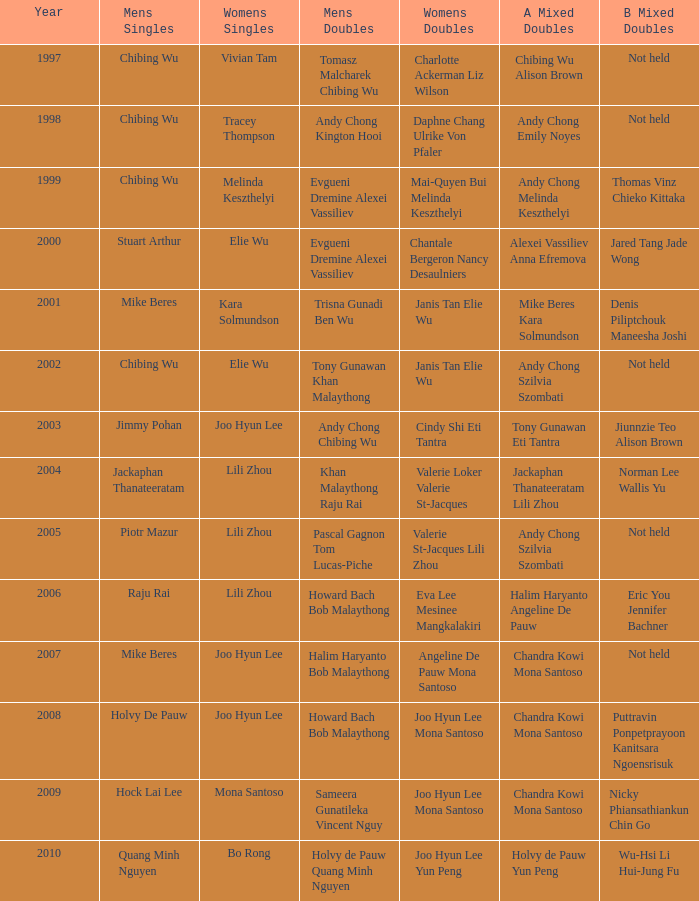What is the least year when men's singles is Raju Rai? 2006.0. Can you parse all the data within this table? {'header': ['Year', 'Mens Singles', 'Womens Singles', 'Mens Doubles', 'Womens Doubles', 'A Mixed Doubles', 'B Mixed Doubles'], 'rows': [['1997', 'Chibing Wu', 'Vivian Tam', 'Tomasz Malcharek Chibing Wu', 'Charlotte Ackerman Liz Wilson', 'Chibing Wu Alison Brown', 'Not held'], ['1998', 'Chibing Wu', 'Tracey Thompson', 'Andy Chong Kington Hooi', 'Daphne Chang Ulrike Von Pfaler', 'Andy Chong Emily Noyes', 'Not held'], ['1999', 'Chibing Wu', 'Melinda Keszthelyi', 'Evgueni Dremine Alexei Vassiliev', 'Mai-Quyen Bui Melinda Keszthelyi', 'Andy Chong Melinda Keszthelyi', 'Thomas Vinz Chieko Kittaka'], ['2000', 'Stuart Arthur', 'Elie Wu', 'Evgueni Dremine Alexei Vassiliev', 'Chantale Bergeron Nancy Desaulniers', 'Alexei Vassiliev Anna Efremova', 'Jared Tang Jade Wong'], ['2001', 'Mike Beres', 'Kara Solmundson', 'Trisna Gunadi Ben Wu', 'Janis Tan Elie Wu', 'Mike Beres Kara Solmundson', 'Denis Piliptchouk Maneesha Joshi'], ['2002', 'Chibing Wu', 'Elie Wu', 'Tony Gunawan Khan Malaythong', 'Janis Tan Elie Wu', 'Andy Chong Szilvia Szombati', 'Not held'], ['2003', 'Jimmy Pohan', 'Joo Hyun Lee', 'Andy Chong Chibing Wu', 'Cindy Shi Eti Tantra', 'Tony Gunawan Eti Tantra', 'Jiunnzie Teo Alison Brown'], ['2004', 'Jackaphan Thanateeratam', 'Lili Zhou', 'Khan Malaythong Raju Rai', 'Valerie Loker Valerie St-Jacques', 'Jackaphan Thanateeratam Lili Zhou', 'Norman Lee Wallis Yu'], ['2005', 'Piotr Mazur', 'Lili Zhou', 'Pascal Gagnon Tom Lucas-Piche', 'Valerie St-Jacques Lili Zhou', 'Andy Chong Szilvia Szombati', 'Not held'], ['2006', 'Raju Rai', 'Lili Zhou', 'Howard Bach Bob Malaythong', 'Eva Lee Mesinee Mangkalakiri', 'Halim Haryanto Angeline De Pauw', 'Eric You Jennifer Bachner'], ['2007', 'Mike Beres', 'Joo Hyun Lee', 'Halim Haryanto Bob Malaythong', 'Angeline De Pauw Mona Santoso', 'Chandra Kowi Mona Santoso', 'Not held'], ['2008', 'Holvy De Pauw', 'Joo Hyun Lee', 'Howard Bach Bob Malaythong', 'Joo Hyun Lee Mona Santoso', 'Chandra Kowi Mona Santoso', 'Puttravin Ponpetprayoon Kanitsara Ngoensrisuk'], ['2009', 'Hock Lai Lee', 'Mona Santoso', 'Sameera Gunatileka Vincent Nguy', 'Joo Hyun Lee Mona Santoso', 'Chandra Kowi Mona Santoso', 'Nicky Phiansathiankun Chin Go'], ['2010', 'Quang Minh Nguyen', 'Bo Rong', 'Holvy de Pauw Quang Minh Nguyen', 'Joo Hyun Lee Yun Peng', 'Holvy de Pauw Yun Peng', 'Wu-Hsi Li Hui-Jung Fu']]} 